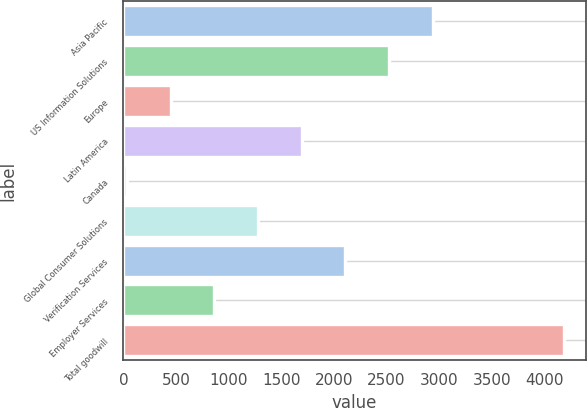Convert chart. <chart><loc_0><loc_0><loc_500><loc_500><bar_chart><fcel>Asia Pacific<fcel>US Information Solutions<fcel>Europe<fcel>Latin America<fcel>Canada<fcel>Global Consumer Solutions<fcel>Verification Services<fcel>Employer Services<fcel>Total goodwill<nl><fcel>2939.3<fcel>2524.4<fcel>449.9<fcel>1694.6<fcel>35<fcel>1279.7<fcel>2109.5<fcel>864.8<fcel>4184<nl></chart> 